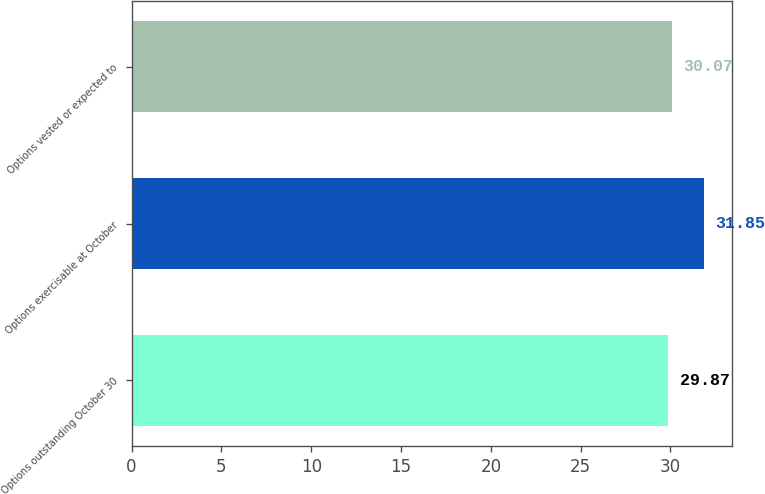<chart> <loc_0><loc_0><loc_500><loc_500><bar_chart><fcel>Options outstanding October 30<fcel>Options exercisable at October<fcel>Options vested or expected to<nl><fcel>29.87<fcel>31.85<fcel>30.07<nl></chart> 